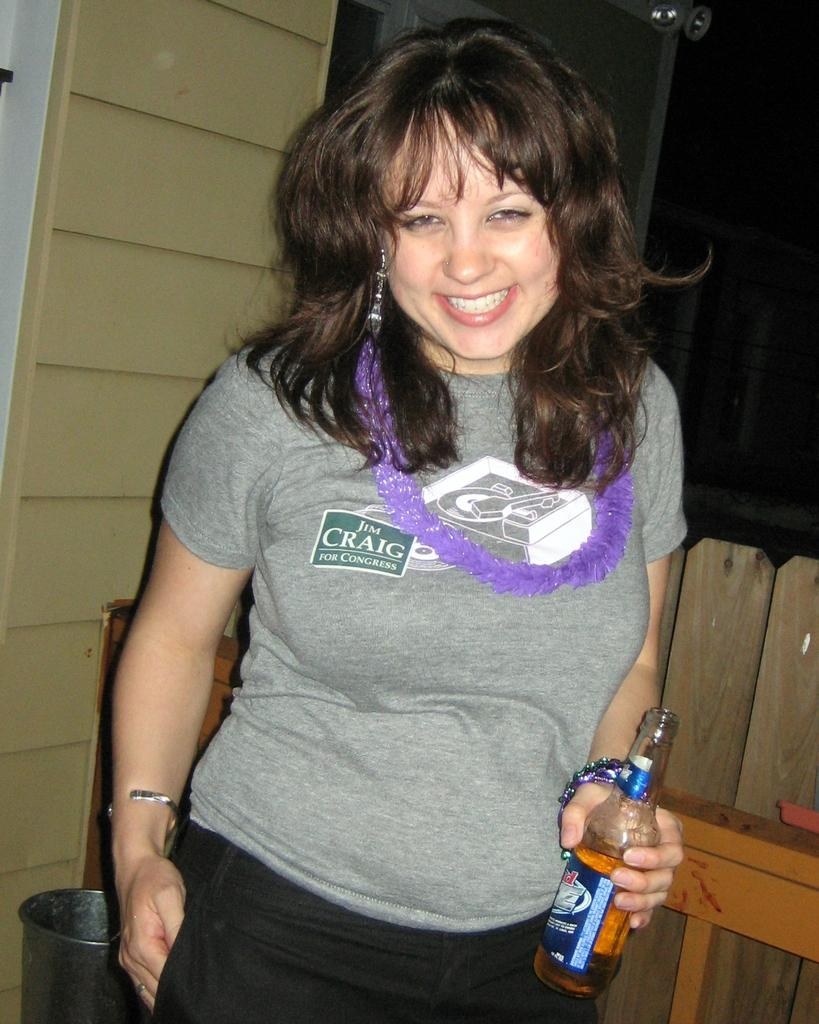Provide a one-sentence caption for the provided image. the woman is wearing a t-shirt saying Jim Craig for Congress. 